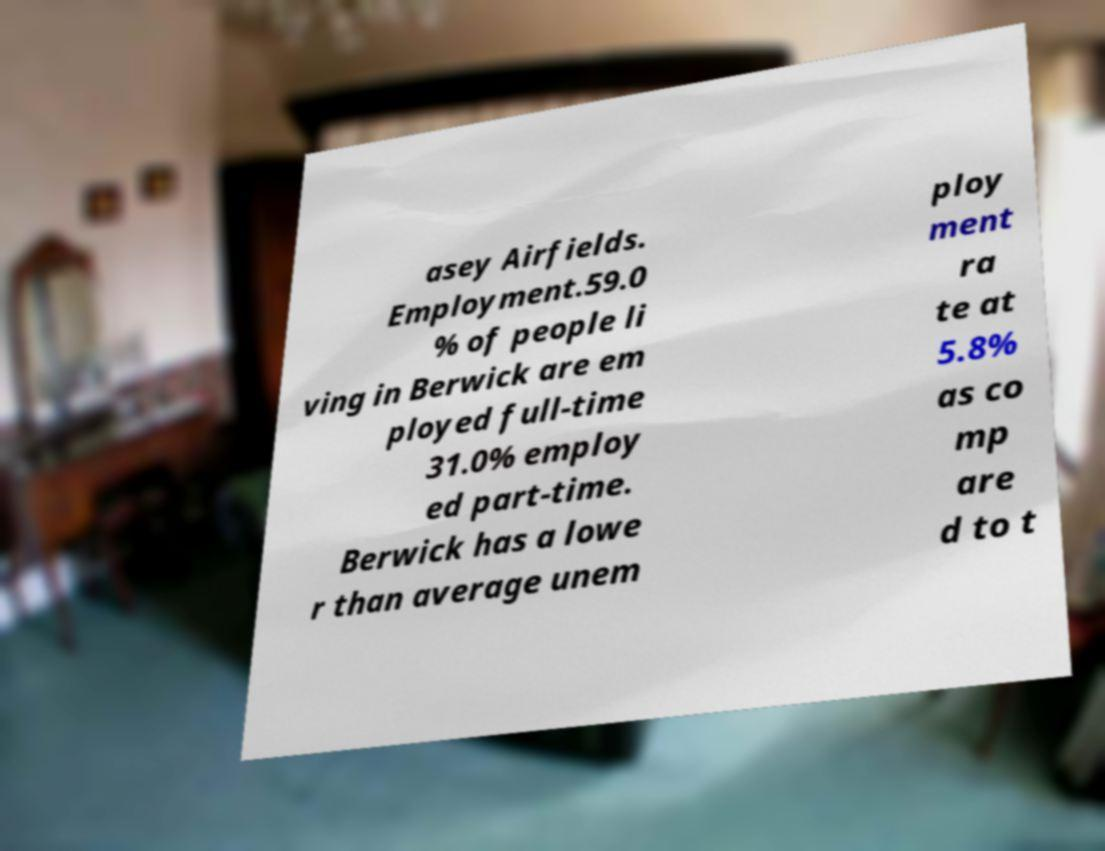Please identify and transcribe the text found in this image. asey Airfields. Employment.59.0 % of people li ving in Berwick are em ployed full-time 31.0% employ ed part-time. Berwick has a lowe r than average unem ploy ment ra te at 5.8% as co mp are d to t 